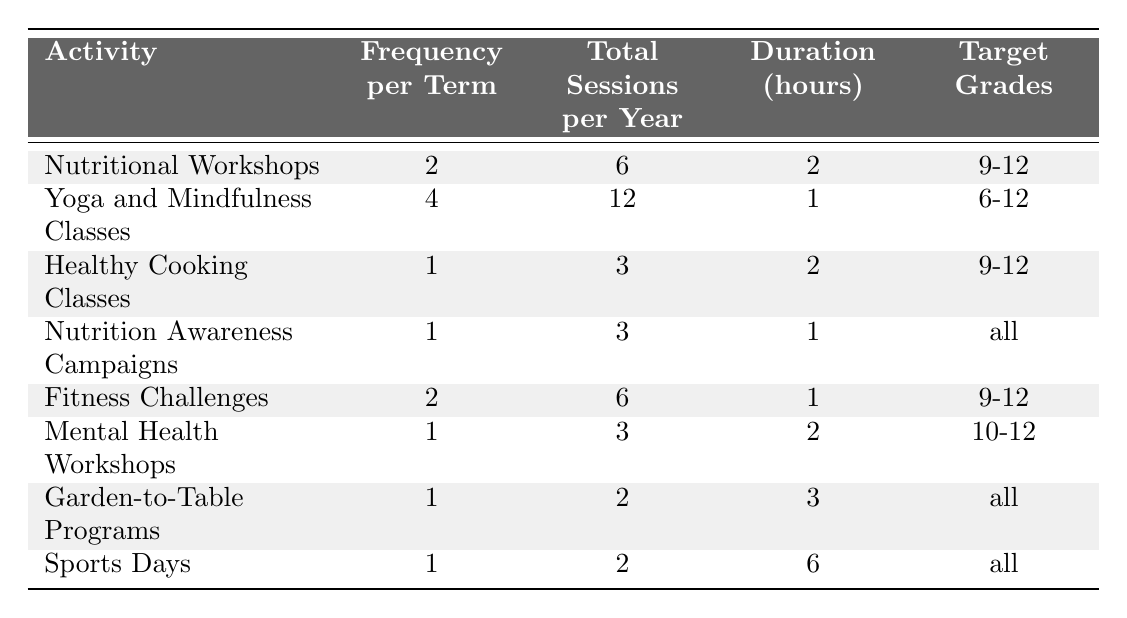What is the total number of sessions for Yoga and Mindfulness Classes in a year? The table states that Yoga and Mindfulness Classes have 12 total sessions per year.
Answer: 12 How many hours is a Nutrition Awareness Campaign session? The table shows that each Nutrition Awareness Campaign lasts for 1 hour.
Answer: 1 hour Which activity is offered to all grade levels? The table indicates that Nutrition Awareness Campaigns, Garden-to-Table Programs, and Sports Days are available for all grade levels.
Answer: Nutrition Awareness Campaigns, Garden-to-Table Programs, Sports Days What is the total duration in hours for all sessions of Nutritional Workshops throughout the year? Nutritional Workshops have 6 sessions, each lasting 2 hours, so the total duration is 6 * 2 = 12 hours.
Answer: 12 hours Which activity has the highest frequency of sessions per term? Comparing the frequencies, Yoga and Mindfulness Classes with 4 sessions per term has the highest frequency.
Answer: Yoga and Mindfulness Classes How many total hours do Fitness Challenges take up in a year? Fitness Challenges have 6 sessions of 1 hour each, totaling 6 hours for the year.
Answer: 6 hours Is there an activity that has a frequency of 1 session per term? Yes, there are several activities that have a frequency of 1 session per term: Healthy Cooking Classes, Nutrition Awareness Campaigns, Mental Health Workshops, Garden-to-Table Programs, and Sports Days.
Answer: Yes What is the range of total sessions offered for the wellness activities listed? The total sessions range from 2 sessions (Garden-to-Table Programs and Sports Days) to 12 sessions (Yoga and Mindfulness Classes).
Answer: 2 to 12 sessions How many more sessions does Yoga and Mindfulness Classes have compared to Healthy Cooking Classes? Yoga and Mindfulness Classes have 12 sessions while Healthy Cooking Classes have 3 sessions; thus, the difference is 12 - 3 = 9 more sessions.
Answer: 9 more sessions What percentage of the total sessions in a year is dedicated to Mental Health Workshops? Mental Health Workshops have 3 sessions out of the total of 6 (Nutritional Workshops) + 12 (Yoga) + 3 (Healthy Cooking) + 3 (Nutrition Awareness) + 6 (Fitness Challenges) + 3 (Mental Health) + 2 (Garden-to-Table) + 2 (Sports Days) = 37 sessions. The percentage is 3/37 * 100 ≈ 8.1%.
Answer: 8.1% 